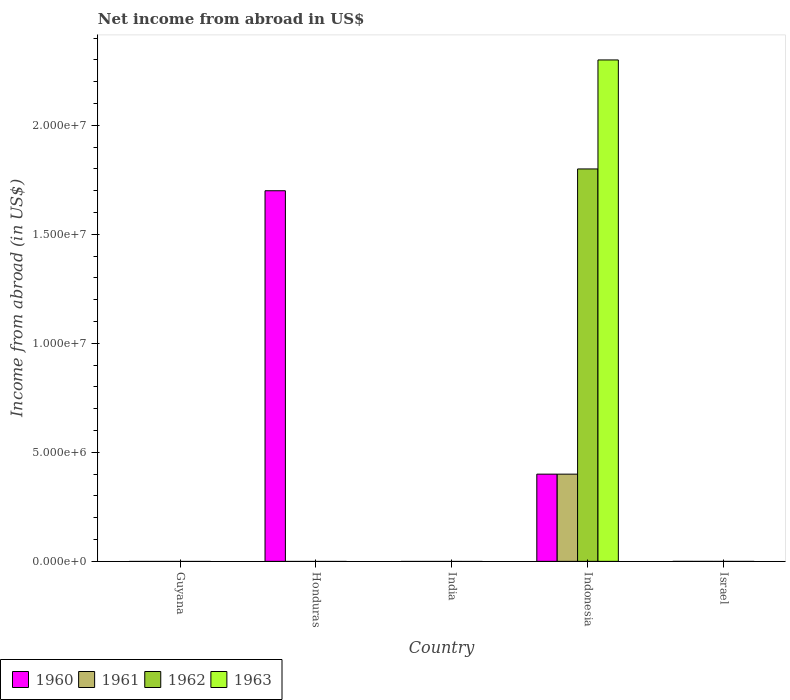Are the number of bars on each tick of the X-axis equal?
Offer a very short reply. No. How many bars are there on the 1st tick from the right?
Offer a terse response. 0. What is the label of the 2nd group of bars from the left?
Keep it short and to the point. Honduras. In how many cases, is the number of bars for a given country not equal to the number of legend labels?
Your response must be concise. 4. Across all countries, what is the maximum net income from abroad in 1960?
Give a very brief answer. 1.70e+07. In which country was the net income from abroad in 1962 maximum?
Offer a very short reply. Indonesia. What is the difference between the net income from abroad in 1960 in Honduras and the net income from abroad in 1963 in Israel?
Provide a short and direct response. 1.70e+07. What is the average net income from abroad in 1962 per country?
Keep it short and to the point. 3.60e+06. What is the difference between the net income from abroad of/in 1961 and net income from abroad of/in 1962 in Indonesia?
Provide a succinct answer. -1.40e+07. What is the difference between the highest and the lowest net income from abroad in 1963?
Keep it short and to the point. 2.30e+07. In how many countries, is the net income from abroad in 1963 greater than the average net income from abroad in 1963 taken over all countries?
Offer a terse response. 1. Is it the case that in every country, the sum of the net income from abroad in 1960 and net income from abroad in 1962 is greater than the sum of net income from abroad in 1961 and net income from abroad in 1963?
Ensure brevity in your answer.  No. Is it the case that in every country, the sum of the net income from abroad in 1962 and net income from abroad in 1963 is greater than the net income from abroad in 1961?
Your response must be concise. No. Are all the bars in the graph horizontal?
Provide a short and direct response. No. Are the values on the major ticks of Y-axis written in scientific E-notation?
Provide a succinct answer. Yes. Does the graph contain any zero values?
Give a very brief answer. Yes. How are the legend labels stacked?
Your answer should be compact. Horizontal. What is the title of the graph?
Ensure brevity in your answer.  Net income from abroad in US$. What is the label or title of the Y-axis?
Provide a short and direct response. Income from abroad (in US$). What is the Income from abroad (in US$) of 1961 in Guyana?
Keep it short and to the point. 0. What is the Income from abroad (in US$) of 1962 in Guyana?
Your response must be concise. 0. What is the Income from abroad (in US$) of 1960 in Honduras?
Give a very brief answer. 1.70e+07. What is the Income from abroad (in US$) of 1961 in Honduras?
Your response must be concise. 0. What is the Income from abroad (in US$) in 1962 in Honduras?
Offer a terse response. 0. What is the Income from abroad (in US$) in 1963 in Honduras?
Provide a succinct answer. 0. What is the Income from abroad (in US$) of 1960 in India?
Make the answer very short. 0. What is the Income from abroad (in US$) of 1962 in India?
Keep it short and to the point. 0. What is the Income from abroad (in US$) of 1963 in India?
Provide a succinct answer. 0. What is the Income from abroad (in US$) in 1960 in Indonesia?
Keep it short and to the point. 4.00e+06. What is the Income from abroad (in US$) in 1961 in Indonesia?
Your answer should be compact. 4.00e+06. What is the Income from abroad (in US$) of 1962 in Indonesia?
Provide a short and direct response. 1.80e+07. What is the Income from abroad (in US$) of 1963 in Indonesia?
Give a very brief answer. 2.30e+07. What is the Income from abroad (in US$) in 1960 in Israel?
Your answer should be compact. 0. What is the Income from abroad (in US$) in 1961 in Israel?
Your answer should be very brief. 0. What is the Income from abroad (in US$) of 1962 in Israel?
Your response must be concise. 0. Across all countries, what is the maximum Income from abroad (in US$) in 1960?
Offer a terse response. 1.70e+07. Across all countries, what is the maximum Income from abroad (in US$) in 1962?
Offer a terse response. 1.80e+07. Across all countries, what is the maximum Income from abroad (in US$) of 1963?
Give a very brief answer. 2.30e+07. Across all countries, what is the minimum Income from abroad (in US$) of 1963?
Give a very brief answer. 0. What is the total Income from abroad (in US$) in 1960 in the graph?
Offer a very short reply. 2.10e+07. What is the total Income from abroad (in US$) of 1962 in the graph?
Provide a succinct answer. 1.80e+07. What is the total Income from abroad (in US$) of 1963 in the graph?
Give a very brief answer. 2.30e+07. What is the difference between the Income from abroad (in US$) of 1960 in Honduras and that in Indonesia?
Give a very brief answer. 1.30e+07. What is the difference between the Income from abroad (in US$) of 1960 in Honduras and the Income from abroad (in US$) of 1961 in Indonesia?
Provide a succinct answer. 1.30e+07. What is the difference between the Income from abroad (in US$) in 1960 in Honduras and the Income from abroad (in US$) in 1962 in Indonesia?
Ensure brevity in your answer.  -1.00e+06. What is the difference between the Income from abroad (in US$) of 1960 in Honduras and the Income from abroad (in US$) of 1963 in Indonesia?
Offer a very short reply. -6.00e+06. What is the average Income from abroad (in US$) in 1960 per country?
Your response must be concise. 4.20e+06. What is the average Income from abroad (in US$) in 1962 per country?
Keep it short and to the point. 3.60e+06. What is the average Income from abroad (in US$) of 1963 per country?
Your response must be concise. 4.60e+06. What is the difference between the Income from abroad (in US$) in 1960 and Income from abroad (in US$) in 1962 in Indonesia?
Your response must be concise. -1.40e+07. What is the difference between the Income from abroad (in US$) of 1960 and Income from abroad (in US$) of 1963 in Indonesia?
Ensure brevity in your answer.  -1.90e+07. What is the difference between the Income from abroad (in US$) in 1961 and Income from abroad (in US$) in 1962 in Indonesia?
Your answer should be very brief. -1.40e+07. What is the difference between the Income from abroad (in US$) in 1961 and Income from abroad (in US$) in 1963 in Indonesia?
Offer a terse response. -1.90e+07. What is the difference between the Income from abroad (in US$) of 1962 and Income from abroad (in US$) of 1963 in Indonesia?
Your response must be concise. -5.00e+06. What is the ratio of the Income from abroad (in US$) in 1960 in Honduras to that in Indonesia?
Make the answer very short. 4.25. What is the difference between the highest and the lowest Income from abroad (in US$) of 1960?
Make the answer very short. 1.70e+07. What is the difference between the highest and the lowest Income from abroad (in US$) in 1961?
Ensure brevity in your answer.  4.00e+06. What is the difference between the highest and the lowest Income from abroad (in US$) of 1962?
Provide a succinct answer. 1.80e+07. What is the difference between the highest and the lowest Income from abroad (in US$) of 1963?
Your answer should be very brief. 2.30e+07. 